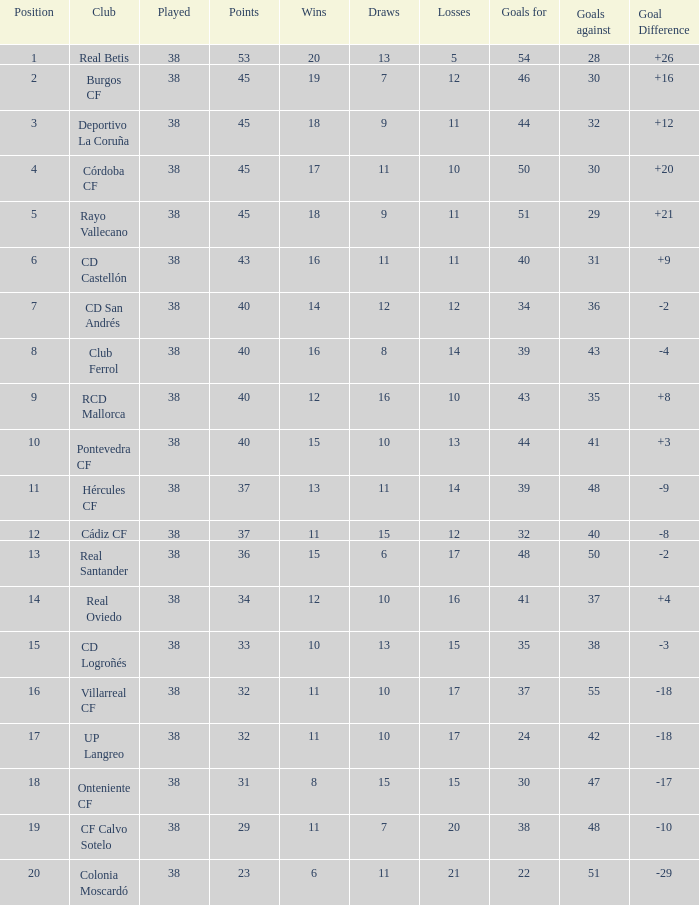What is the mean played, when club is "burgos cf", and when draws is fewer than 7? None. 